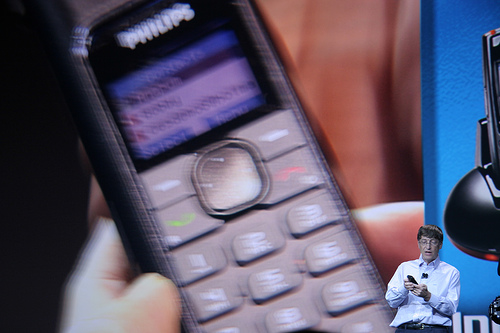<image>
Is the phone above the person? No. The phone is not positioned above the person. The vertical arrangement shows a different relationship. 